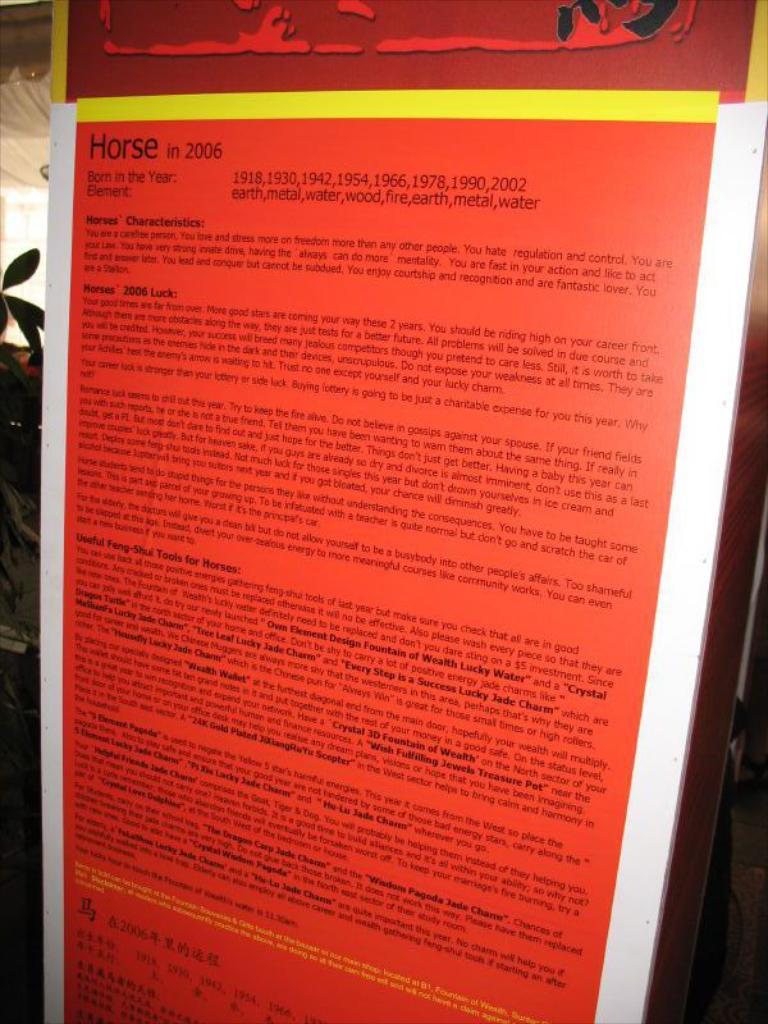<image>
Describe the image concisely. the word horse is on the orange list 